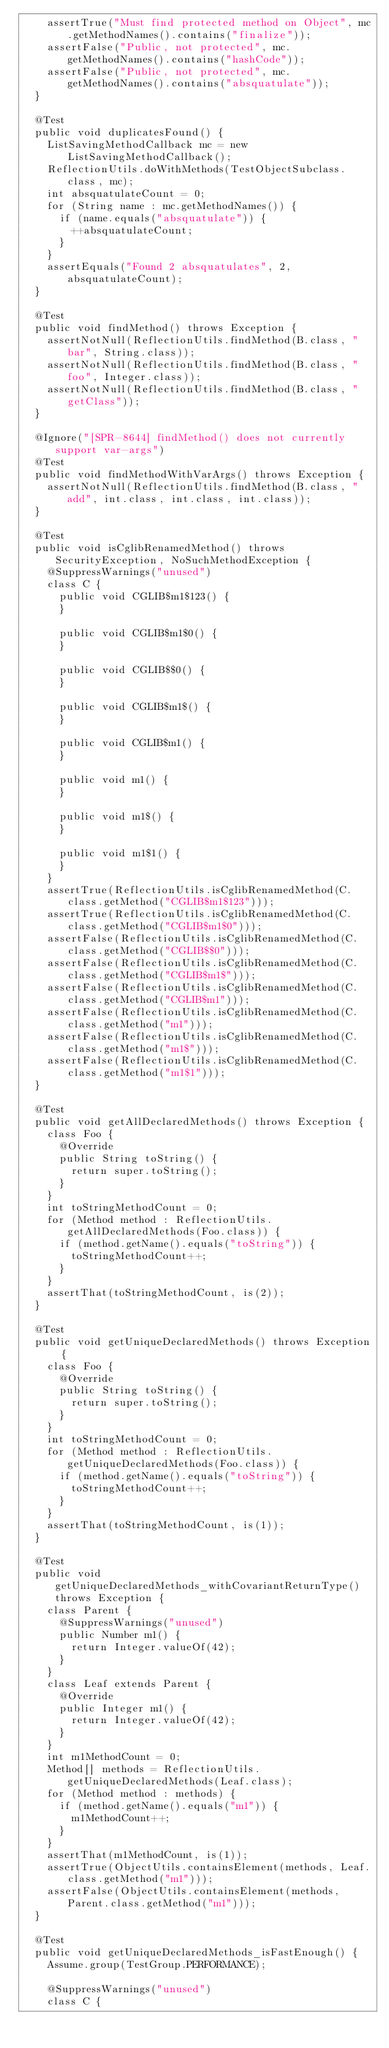Convert code to text. <code><loc_0><loc_0><loc_500><loc_500><_Java_>		assertTrue("Must find protected method on Object", mc.getMethodNames().contains("finalize"));
		assertFalse("Public, not protected", mc.getMethodNames().contains("hashCode"));
		assertFalse("Public, not protected", mc.getMethodNames().contains("absquatulate"));
	}

	@Test
	public void duplicatesFound() {
		ListSavingMethodCallback mc = new ListSavingMethodCallback();
		ReflectionUtils.doWithMethods(TestObjectSubclass.class, mc);
		int absquatulateCount = 0;
		for (String name : mc.getMethodNames()) {
			if (name.equals("absquatulate")) {
				++absquatulateCount;
			}
		}
		assertEquals("Found 2 absquatulates", 2, absquatulateCount);
	}

	@Test
	public void findMethod() throws Exception {
		assertNotNull(ReflectionUtils.findMethod(B.class, "bar", String.class));
		assertNotNull(ReflectionUtils.findMethod(B.class, "foo", Integer.class));
		assertNotNull(ReflectionUtils.findMethod(B.class, "getClass"));
	}

	@Ignore("[SPR-8644] findMethod() does not currently support var-args")
	@Test
	public void findMethodWithVarArgs() throws Exception {
		assertNotNull(ReflectionUtils.findMethod(B.class, "add", int.class, int.class, int.class));
	}

	@Test
	public void isCglibRenamedMethod() throws SecurityException, NoSuchMethodException {
		@SuppressWarnings("unused")
		class C {
			public void CGLIB$m1$123() {
			}

			public void CGLIB$m1$0() {
			}

			public void CGLIB$$0() {
			}

			public void CGLIB$m1$() {
			}

			public void CGLIB$m1() {
			}

			public void m1() {
			}

			public void m1$() {
			}

			public void m1$1() {
			}
		}
		assertTrue(ReflectionUtils.isCglibRenamedMethod(C.class.getMethod("CGLIB$m1$123")));
		assertTrue(ReflectionUtils.isCglibRenamedMethod(C.class.getMethod("CGLIB$m1$0")));
		assertFalse(ReflectionUtils.isCglibRenamedMethod(C.class.getMethod("CGLIB$$0")));
		assertFalse(ReflectionUtils.isCglibRenamedMethod(C.class.getMethod("CGLIB$m1$")));
		assertFalse(ReflectionUtils.isCglibRenamedMethod(C.class.getMethod("CGLIB$m1")));
		assertFalse(ReflectionUtils.isCglibRenamedMethod(C.class.getMethod("m1")));
		assertFalse(ReflectionUtils.isCglibRenamedMethod(C.class.getMethod("m1$")));
		assertFalse(ReflectionUtils.isCglibRenamedMethod(C.class.getMethod("m1$1")));
	}

	@Test
	public void getAllDeclaredMethods() throws Exception {
		class Foo {
			@Override
			public String toString() {
				return super.toString();
			}
		}
		int toStringMethodCount = 0;
		for (Method method : ReflectionUtils.getAllDeclaredMethods(Foo.class)) {
			if (method.getName().equals("toString")) {
				toStringMethodCount++;
			}
		}
		assertThat(toStringMethodCount, is(2));
	}

	@Test
	public void getUniqueDeclaredMethods() throws Exception {
		class Foo {
			@Override
			public String toString() {
				return super.toString();
			}
		}
		int toStringMethodCount = 0;
		for (Method method : ReflectionUtils.getUniqueDeclaredMethods(Foo.class)) {
			if (method.getName().equals("toString")) {
				toStringMethodCount++;
			}
		}
		assertThat(toStringMethodCount, is(1));
	}

	@Test
	public void getUniqueDeclaredMethods_withCovariantReturnType() throws Exception {
		class Parent {
			@SuppressWarnings("unused")
			public Number m1() {
				return Integer.valueOf(42);
			}
		}
		class Leaf extends Parent {
			@Override
			public Integer m1() {
				return Integer.valueOf(42);
			}
		}
		int m1MethodCount = 0;
		Method[] methods = ReflectionUtils.getUniqueDeclaredMethods(Leaf.class);
		for (Method method : methods) {
			if (method.getName().equals("m1")) {
				m1MethodCount++;
			}
		}
		assertThat(m1MethodCount, is(1));
		assertTrue(ObjectUtils.containsElement(methods, Leaf.class.getMethod("m1")));
		assertFalse(ObjectUtils.containsElement(methods, Parent.class.getMethod("m1")));
	}

	@Test
	public void getUniqueDeclaredMethods_isFastEnough() {
		Assume.group(TestGroup.PERFORMANCE);

		@SuppressWarnings("unused")
		class C {</code> 